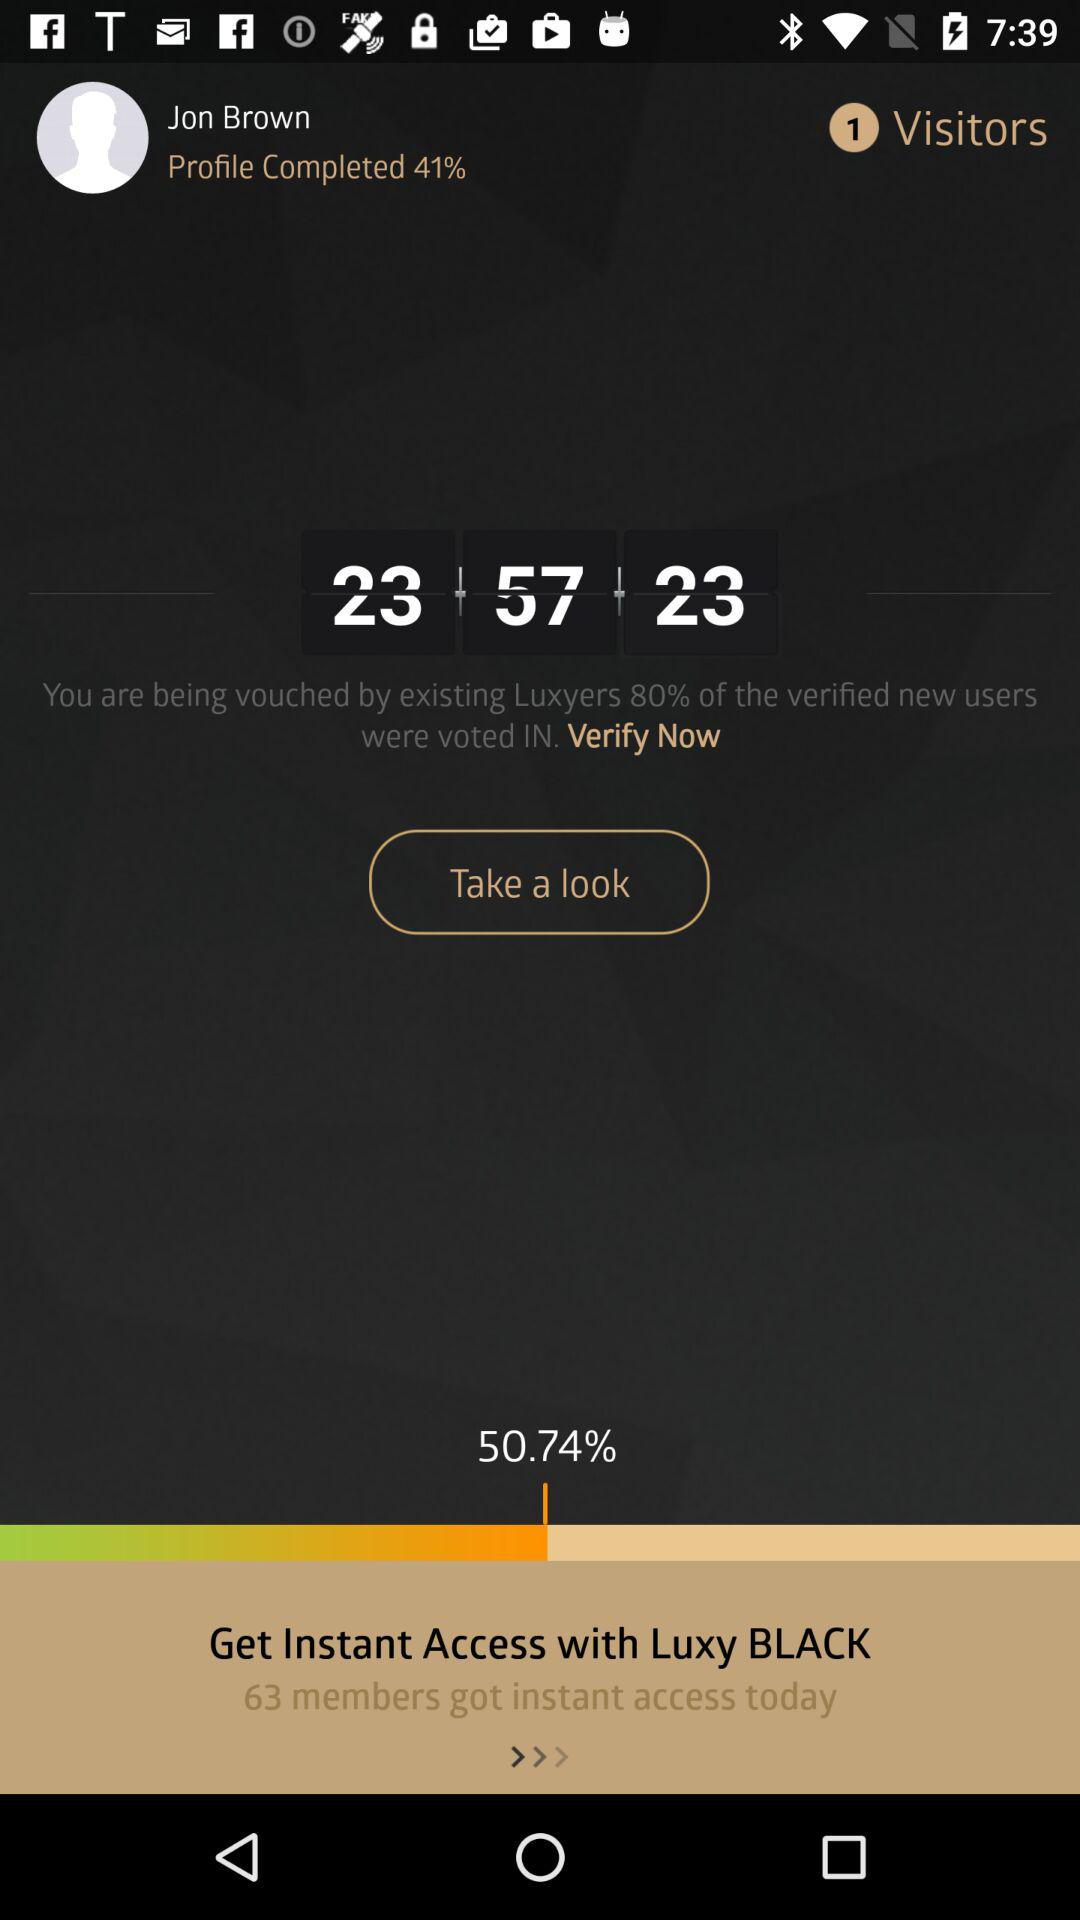What is the percent of the profile completed? The percentage is 41. 